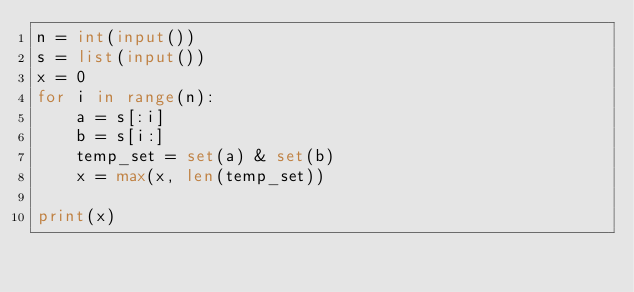<code> <loc_0><loc_0><loc_500><loc_500><_Python_>n = int(input())
s = list(input())
x = 0
for i in range(n):
    a = s[:i]
    b = s[i:]
    temp_set = set(a) & set(b)
    x = max(x, len(temp_set))

print(x)</code> 